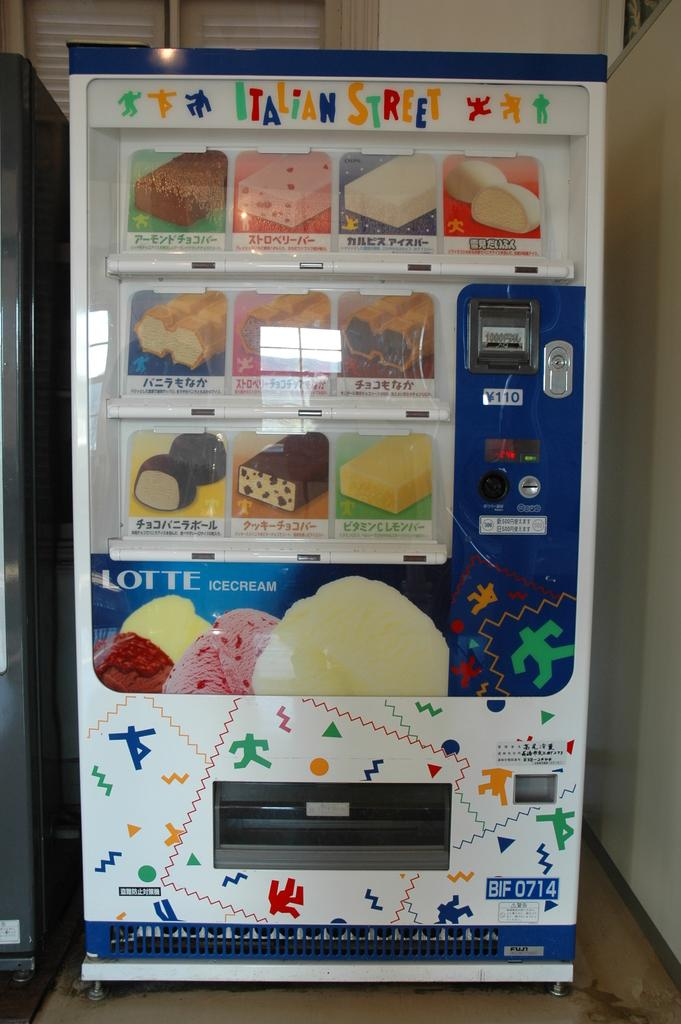Provide a one-sentence caption for the provided image. A vending machine that sells ice cream called Italian Street. 